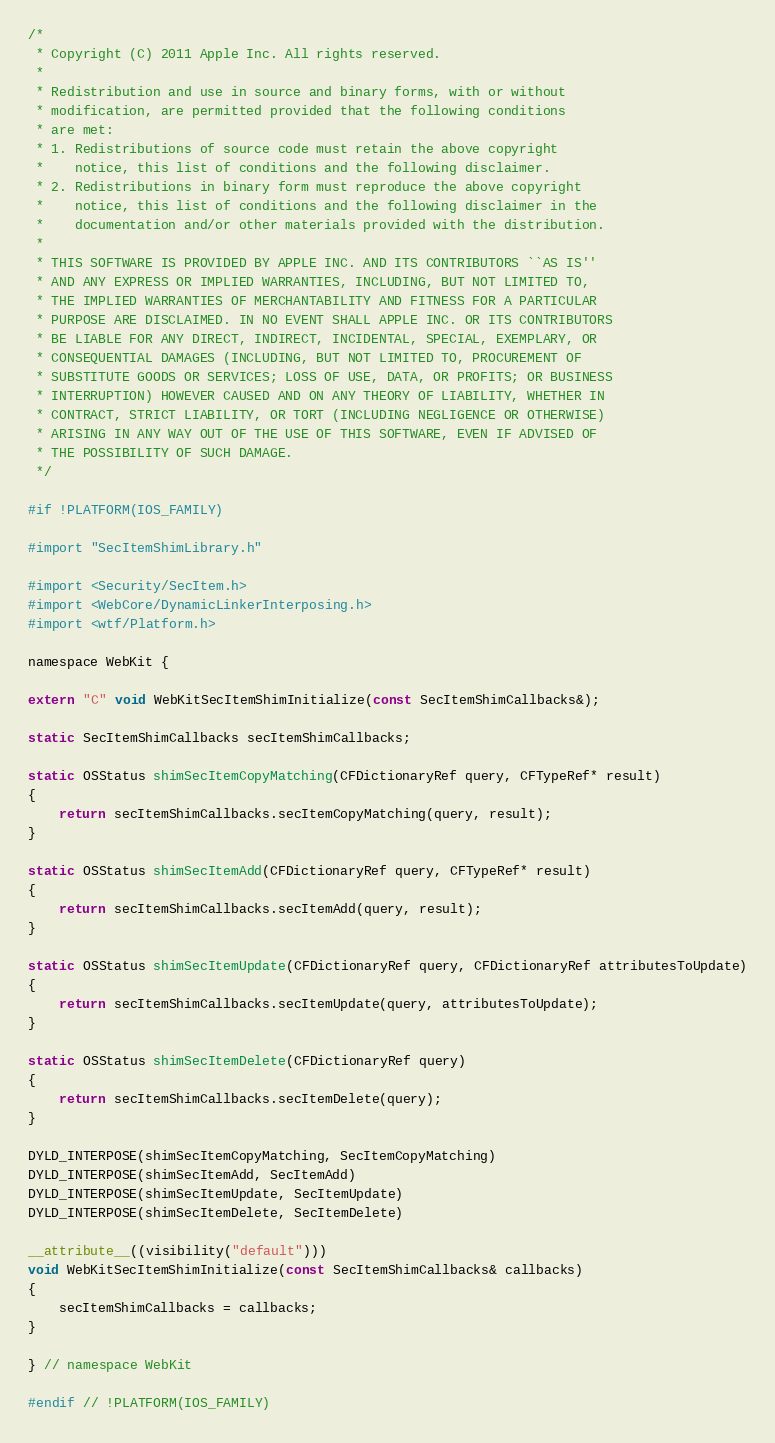Convert code to text. <code><loc_0><loc_0><loc_500><loc_500><_ObjectiveC_>/*
 * Copyright (C) 2011 Apple Inc. All rights reserved.
 *
 * Redistribution and use in source and binary forms, with or without
 * modification, are permitted provided that the following conditions
 * are met:
 * 1. Redistributions of source code must retain the above copyright
 *    notice, this list of conditions and the following disclaimer.
 * 2. Redistributions in binary form must reproduce the above copyright
 *    notice, this list of conditions and the following disclaimer in the
 *    documentation and/or other materials provided with the distribution.
 *
 * THIS SOFTWARE IS PROVIDED BY APPLE INC. AND ITS CONTRIBUTORS ``AS IS''
 * AND ANY EXPRESS OR IMPLIED WARRANTIES, INCLUDING, BUT NOT LIMITED TO,
 * THE IMPLIED WARRANTIES OF MERCHANTABILITY AND FITNESS FOR A PARTICULAR
 * PURPOSE ARE DISCLAIMED. IN NO EVENT SHALL APPLE INC. OR ITS CONTRIBUTORS
 * BE LIABLE FOR ANY DIRECT, INDIRECT, INCIDENTAL, SPECIAL, EXEMPLARY, OR
 * CONSEQUENTIAL DAMAGES (INCLUDING, BUT NOT LIMITED TO, PROCUREMENT OF
 * SUBSTITUTE GOODS OR SERVICES; LOSS OF USE, DATA, OR PROFITS; OR BUSINESS
 * INTERRUPTION) HOWEVER CAUSED AND ON ANY THEORY OF LIABILITY, WHETHER IN
 * CONTRACT, STRICT LIABILITY, OR TORT (INCLUDING NEGLIGENCE OR OTHERWISE)
 * ARISING IN ANY WAY OUT OF THE USE OF THIS SOFTWARE, EVEN IF ADVISED OF
 * THE POSSIBILITY OF SUCH DAMAGE.
 */

#if !PLATFORM(IOS_FAMILY)

#import "SecItemShimLibrary.h"

#import <Security/SecItem.h>
#import <WebCore/DynamicLinkerInterposing.h>
#import <wtf/Platform.h>

namespace WebKit {

extern "C" void WebKitSecItemShimInitialize(const SecItemShimCallbacks&);

static SecItemShimCallbacks secItemShimCallbacks;

static OSStatus shimSecItemCopyMatching(CFDictionaryRef query, CFTypeRef* result)
{
    return secItemShimCallbacks.secItemCopyMatching(query, result);
}

static OSStatus shimSecItemAdd(CFDictionaryRef query, CFTypeRef* result)
{
    return secItemShimCallbacks.secItemAdd(query, result);
}

static OSStatus shimSecItemUpdate(CFDictionaryRef query, CFDictionaryRef attributesToUpdate)
{
    return secItemShimCallbacks.secItemUpdate(query, attributesToUpdate);
}

static OSStatus shimSecItemDelete(CFDictionaryRef query)
{
    return secItemShimCallbacks.secItemDelete(query);
}

DYLD_INTERPOSE(shimSecItemCopyMatching, SecItemCopyMatching)
DYLD_INTERPOSE(shimSecItemAdd, SecItemAdd)
DYLD_INTERPOSE(shimSecItemUpdate, SecItemUpdate)
DYLD_INTERPOSE(shimSecItemDelete, SecItemDelete)

__attribute__((visibility("default")))
void WebKitSecItemShimInitialize(const SecItemShimCallbacks& callbacks)
{
    secItemShimCallbacks = callbacks;
}

} // namespace WebKit

#endif // !PLATFORM(IOS_FAMILY)
</code> 